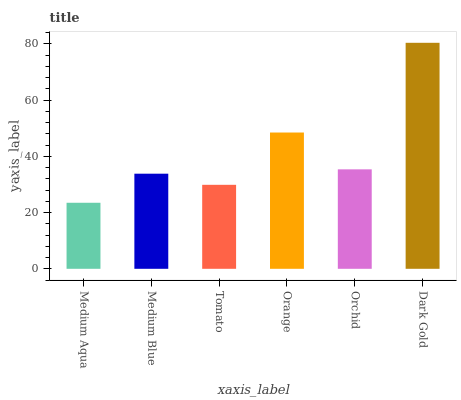Is Medium Aqua the minimum?
Answer yes or no. Yes. Is Dark Gold the maximum?
Answer yes or no. Yes. Is Medium Blue the minimum?
Answer yes or no. No. Is Medium Blue the maximum?
Answer yes or no. No. Is Medium Blue greater than Medium Aqua?
Answer yes or no. Yes. Is Medium Aqua less than Medium Blue?
Answer yes or no. Yes. Is Medium Aqua greater than Medium Blue?
Answer yes or no. No. Is Medium Blue less than Medium Aqua?
Answer yes or no. No. Is Orchid the high median?
Answer yes or no. Yes. Is Medium Blue the low median?
Answer yes or no. Yes. Is Orange the high median?
Answer yes or no. No. Is Orchid the low median?
Answer yes or no. No. 